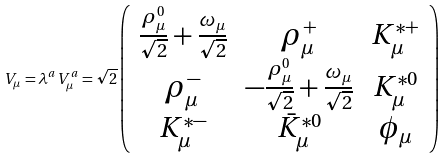Convert formula to latex. <formula><loc_0><loc_0><loc_500><loc_500>V _ { \mu } = \lambda ^ { a } V _ { \mu } ^ { a } = \sqrt { 2 } \left ( \begin{array} { c c c } { { \frac { \rho _ { \mu } ^ { 0 } } { \sqrt { 2 } } + \frac { \omega _ { \mu } } { \sqrt { 2 } } } } & { { \rho _ { \mu } ^ { + } } } & { { K _ { \mu } ^ { * + } } } \\ { { \rho _ { \mu } ^ { - } } } & { { - \frac { \rho _ { \mu } ^ { 0 } } { \sqrt { 2 } } + \frac { \omega _ { \mu } } { \sqrt { 2 } } } } & { { K _ { \mu } ^ { * 0 } } } \\ { { K _ { \mu } ^ { * - } } } & { { \bar { K } _ { \mu } ^ { * 0 } } } & { { \phi _ { \mu } } } \end{array} \right )</formula> 